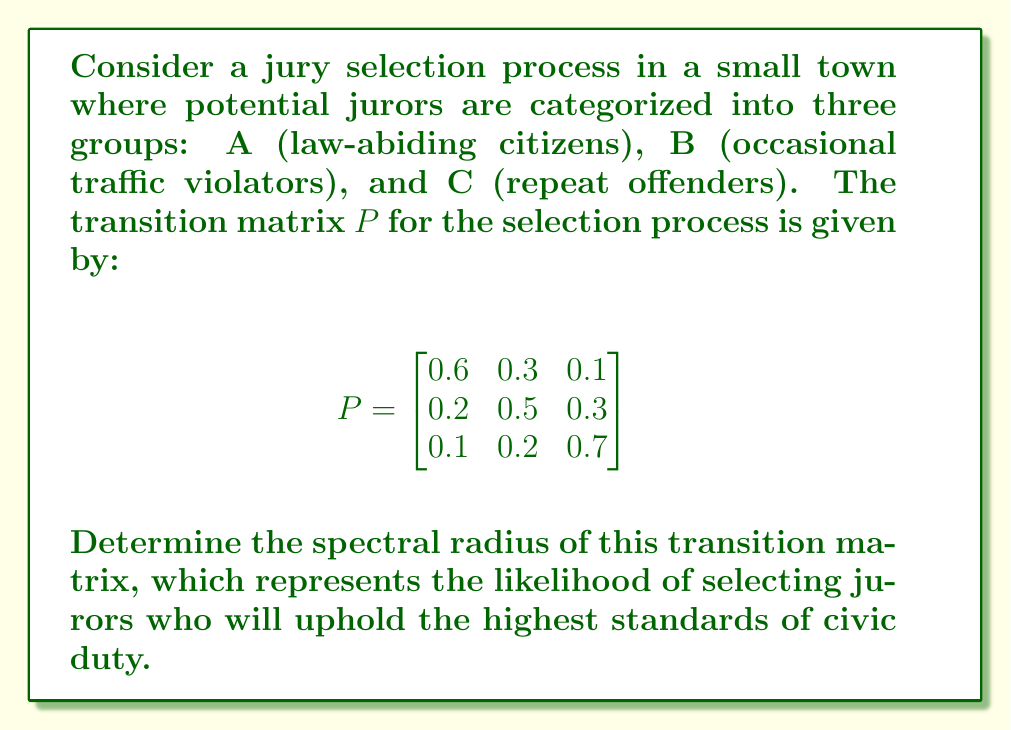Solve this math problem. To find the spectral radius of the transition matrix $P$, we need to follow these steps:

1) First, we need to find the eigenvalues of the matrix $P$. The characteristic equation is:

   $$det(P - \lambda I) = 0$$

2) Expanding this, we get:

   $$(0.6 - \lambda)(0.5 - \lambda)(0.7 - \lambda) - 0.3 \cdot 0.2 \cdot 0.1 - 0.1 \cdot 0.3 \cdot 0.2 - 0.1 \cdot 0.5 \cdot 0.1 - 0.6 \cdot 0.3 \cdot 0.2 - 0.2 \cdot 0.2 \cdot 0.7 = 0$$

3) Simplifying:

   $$-\lambda^3 + 1.8\lambda^2 - 0.97\lambda + 0.158 = 0$$

4) This cubic equation can be solved using numerical methods. The eigenvalues are approximately:

   $$\lambda_1 \approx 1, \lambda_2 \approx 0.5, \lambda_3 \approx 0.3$$

5) The spectral radius is the maximum absolute value of the eigenvalues:

   $$\rho(P) = \max(|\lambda_1|, |\lambda_2|, |\lambda_3|) = \max(1, 0.5, 0.3) = 1$$

6) The spectral radius being 1 indicates that the selection process is stable and will converge to a steady-state distribution of jurors over time.
Answer: $1$ 